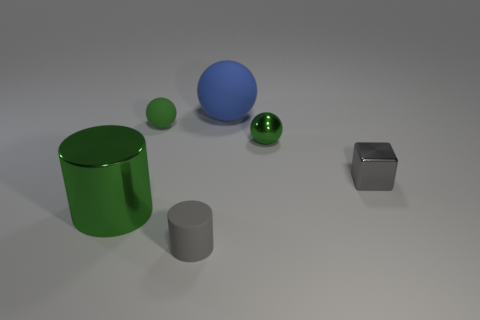There is a tiny shiny ball; does it have the same color as the matte thing on the left side of the rubber cylinder?
Keep it short and to the point. Yes. Are there any other things that are the same color as the big sphere?
Make the answer very short. No. Do the block and the tiny green object behind the green shiny ball have the same material?
Provide a succinct answer. No. There is a object that is on the left side of the matte thing to the left of the small gray rubber object; what is its shape?
Keep it short and to the point. Cylinder. The green thing that is behind the big green metal object and in front of the green rubber ball has what shape?
Keep it short and to the point. Sphere. How many things are either small red balls or tiny metallic objects to the right of the tiny green metallic ball?
Give a very brief answer. 1. There is another object that is the same shape as the large green metallic object; what is its material?
Make the answer very short. Rubber. The tiny thing that is behind the small gray metallic block and right of the small rubber sphere is made of what material?
Make the answer very short. Metal. How many blue rubber things have the same shape as the small gray rubber object?
Ensure brevity in your answer.  0. What is the color of the large thing in front of the green thing right of the large blue ball?
Your answer should be compact. Green. 